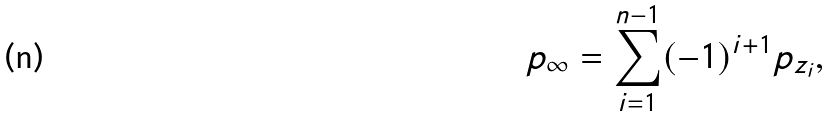Convert formula to latex. <formula><loc_0><loc_0><loc_500><loc_500>p _ { \infty } = \sum _ { i = 1 } ^ { n - 1 } ( - 1 ) ^ { i + 1 } p _ { z _ { i } } ,</formula> 